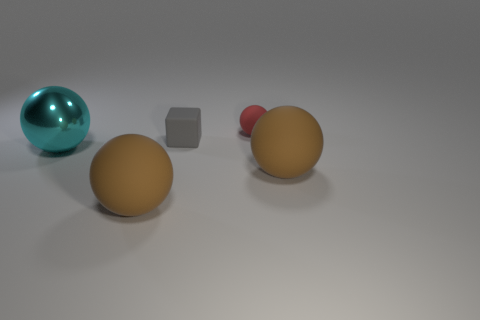Subtract all brown blocks. Subtract all gray cylinders. How many blocks are left? 1 Add 3 cyan metallic cylinders. How many objects exist? 8 Subtract all spheres. How many objects are left? 1 Subtract 0 green cubes. How many objects are left? 5 Subtract all brown matte balls. Subtract all cyan objects. How many objects are left? 2 Add 5 big brown matte objects. How many big brown matte objects are left? 7 Add 3 rubber things. How many rubber things exist? 7 